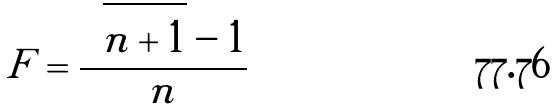<formula> <loc_0><loc_0><loc_500><loc_500>F = \frac { \sqrt { n + 1 } - 1 } { n }</formula> 